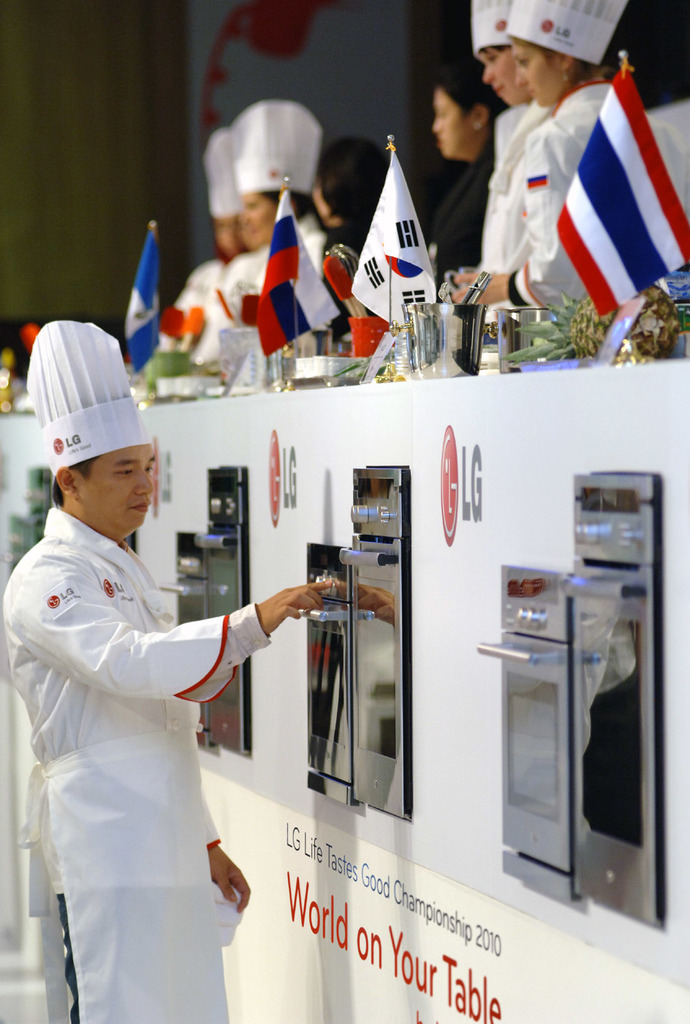What cuisines are these chefs likely preparing, and which countries might they represent? The chefs could be preparing a variety of global cuisines, as indicated by the flags representing South Korea, Russia, Thailand, and the Netherlands. They are likely showcasing signature dishes from their respective countries. Can you tell me more about the significance of this event? The LG Life Tastes Good Championship is an international culinary competition that highlights innovation and expertise in cooking. It brings together top chefs to promote cultural exchange and culinary excellence. 